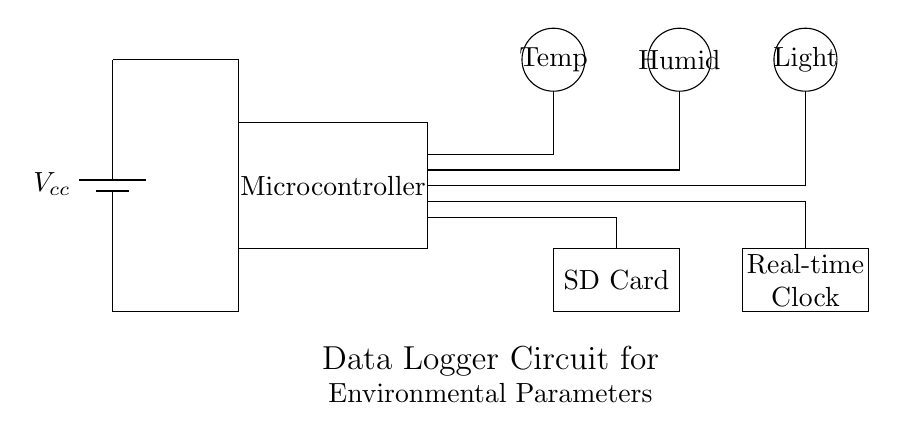What is the main function of the microcontroller in this circuit? The microcontroller acts as the central processing unit, managing data from sensors and controlling the data logging functions.
Answer: Central processing unit What type of sensors are present in the circuit? The circuit includes temperature, humidity, and light sensors which are responsible for monitoring environmental parameters.
Answer: Temperature, humidity, light How is the data from the sensors stored? The data from the sensors is stored on an SD card, which allows for long-term storage of environmental data collected by the circuit.
Answer: SD card What is the purpose of the real-time clock in this circuit? The real-time clock provides accurate timestamping for the data collected, ensuring that environmental parameters are logged with their corresponding times.
Answer: Timestamping What kind of power source is utilized in this circuit? The circuit uses a battery as its power source, providing the necessary voltage to power all components of the system.
Answer: Battery How many sensors are connected to the microcontroller? The microcontroller connects to three sensors: one for temperature, one for humidity, and one for light.
Answer: Three What is the voltage across the battery shown in the circuit? The battery voltage is denoted as Vcc, which typically represents a supply voltage used by the circuit components.
Answer: Vcc 